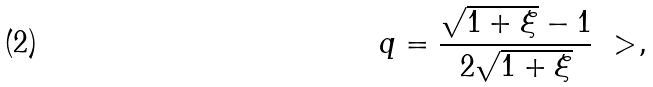<formula> <loc_0><loc_0><loc_500><loc_500>q = \frac { \sqrt { 1 + \xi } - 1 } { 2 \sqrt { 1 + \xi } } \ > ,</formula> 